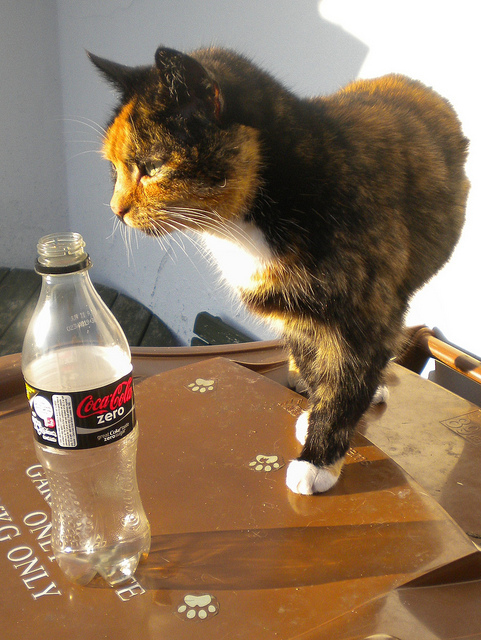Please identify all text content in this image. COCA COLA zero ONLY 89 